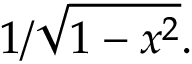Convert formula to latex. <formula><loc_0><loc_0><loc_500><loc_500>1 / { \sqrt { 1 - x ^ { 2 } } } .</formula> 